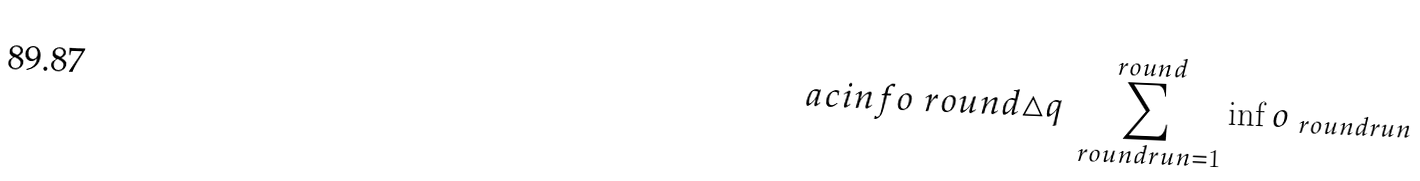Convert formula to latex. <formula><loc_0><loc_0><loc_500><loc_500>\ a c i n f o { \ r o u n d } \triangle q \sum _ { \ r o u n d r u n = 1 } ^ { \ r o u n d } \inf o _ { \ r o u n d r u n }</formula> 